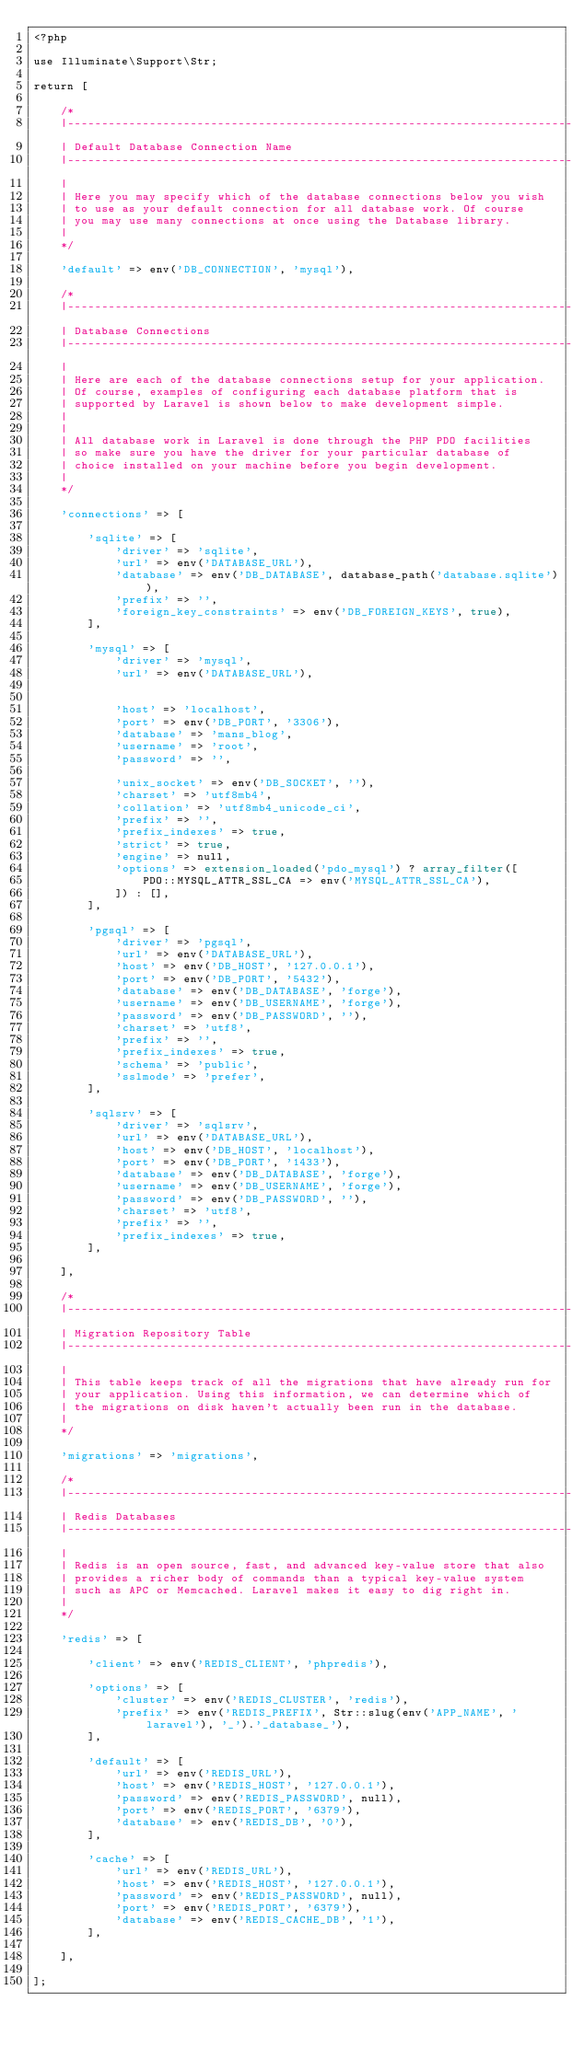Convert code to text. <code><loc_0><loc_0><loc_500><loc_500><_PHP_><?php

use Illuminate\Support\Str;

return [

    /*
    |--------------------------------------------------------------------------
    | Default Database Connection Name
    |--------------------------------------------------------------------------
    |
    | Here you may specify which of the database connections below you wish
    | to use as your default connection for all database work. Of course
    | you may use many connections at once using the Database library.
    |
    */

    'default' => env('DB_CONNECTION', 'mysql'),

    /*
    |--------------------------------------------------------------------------
    | Database Connections
    |--------------------------------------------------------------------------
    |
    | Here are each of the database connections setup for your application.
    | Of course, examples of configuring each database platform that is
    | supported by Laravel is shown below to make development simple.
    |
    |
    | All database work in Laravel is done through the PHP PDO facilities
    | so make sure you have the driver for your particular database of
    | choice installed on your machine before you begin development.
    |
    */

    'connections' => [

        'sqlite' => [
            'driver' => 'sqlite',
            'url' => env('DATABASE_URL'),
            'database' => env('DB_DATABASE', database_path('database.sqlite')),
            'prefix' => '',
            'foreign_key_constraints' => env('DB_FOREIGN_KEYS', true),
        ],

        'mysql' => [
            'driver' => 'mysql',
            'url' => env('DATABASE_URL'),


            'host' => 'localhost',
            'port' => env('DB_PORT', '3306'),
            'database' => 'mans_blog',
            'username' => 'root',
            'password' => '',
            
            'unix_socket' => env('DB_SOCKET', ''),
            'charset' => 'utf8mb4',
            'collation' => 'utf8mb4_unicode_ci',
            'prefix' => '',
            'prefix_indexes' => true,
            'strict' => true,
            'engine' => null,
            'options' => extension_loaded('pdo_mysql') ? array_filter([
                PDO::MYSQL_ATTR_SSL_CA => env('MYSQL_ATTR_SSL_CA'),
            ]) : [],
        ],

        'pgsql' => [
            'driver' => 'pgsql',
            'url' => env('DATABASE_URL'),
            'host' => env('DB_HOST', '127.0.0.1'),
            'port' => env('DB_PORT', '5432'),
            'database' => env('DB_DATABASE', 'forge'),
            'username' => env('DB_USERNAME', 'forge'),
            'password' => env('DB_PASSWORD', ''),
            'charset' => 'utf8',
            'prefix' => '',
            'prefix_indexes' => true,
            'schema' => 'public',
            'sslmode' => 'prefer',
        ],

        'sqlsrv' => [
            'driver' => 'sqlsrv',
            'url' => env('DATABASE_URL'),
            'host' => env('DB_HOST', 'localhost'),
            'port' => env('DB_PORT', '1433'),
            'database' => env('DB_DATABASE', 'forge'),
            'username' => env('DB_USERNAME', 'forge'),
            'password' => env('DB_PASSWORD', ''),
            'charset' => 'utf8',
            'prefix' => '',
            'prefix_indexes' => true,
        ],

    ],

    /*
    |--------------------------------------------------------------------------
    | Migration Repository Table
    |--------------------------------------------------------------------------
    |
    | This table keeps track of all the migrations that have already run for
    | your application. Using this information, we can determine which of
    | the migrations on disk haven't actually been run in the database.
    |
    */

    'migrations' => 'migrations',

    /*
    |--------------------------------------------------------------------------
    | Redis Databases
    |--------------------------------------------------------------------------
    |
    | Redis is an open source, fast, and advanced key-value store that also
    | provides a richer body of commands than a typical key-value system
    | such as APC or Memcached. Laravel makes it easy to dig right in.
    |
    */

    'redis' => [

        'client' => env('REDIS_CLIENT', 'phpredis'),

        'options' => [
            'cluster' => env('REDIS_CLUSTER', 'redis'),
            'prefix' => env('REDIS_PREFIX', Str::slug(env('APP_NAME', 'laravel'), '_').'_database_'),
        ],

        'default' => [
            'url' => env('REDIS_URL'),
            'host' => env('REDIS_HOST', '127.0.0.1'),
            'password' => env('REDIS_PASSWORD', null),
            'port' => env('REDIS_PORT', '6379'),
            'database' => env('REDIS_DB', '0'),
        ],

        'cache' => [
            'url' => env('REDIS_URL'),
            'host' => env('REDIS_HOST', '127.0.0.1'),
            'password' => env('REDIS_PASSWORD', null),
            'port' => env('REDIS_PORT', '6379'),
            'database' => env('REDIS_CACHE_DB', '1'),
        ],

    ],

];
</code> 